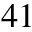<formula> <loc_0><loc_0><loc_500><loc_500>^ { 4 1 }</formula> 